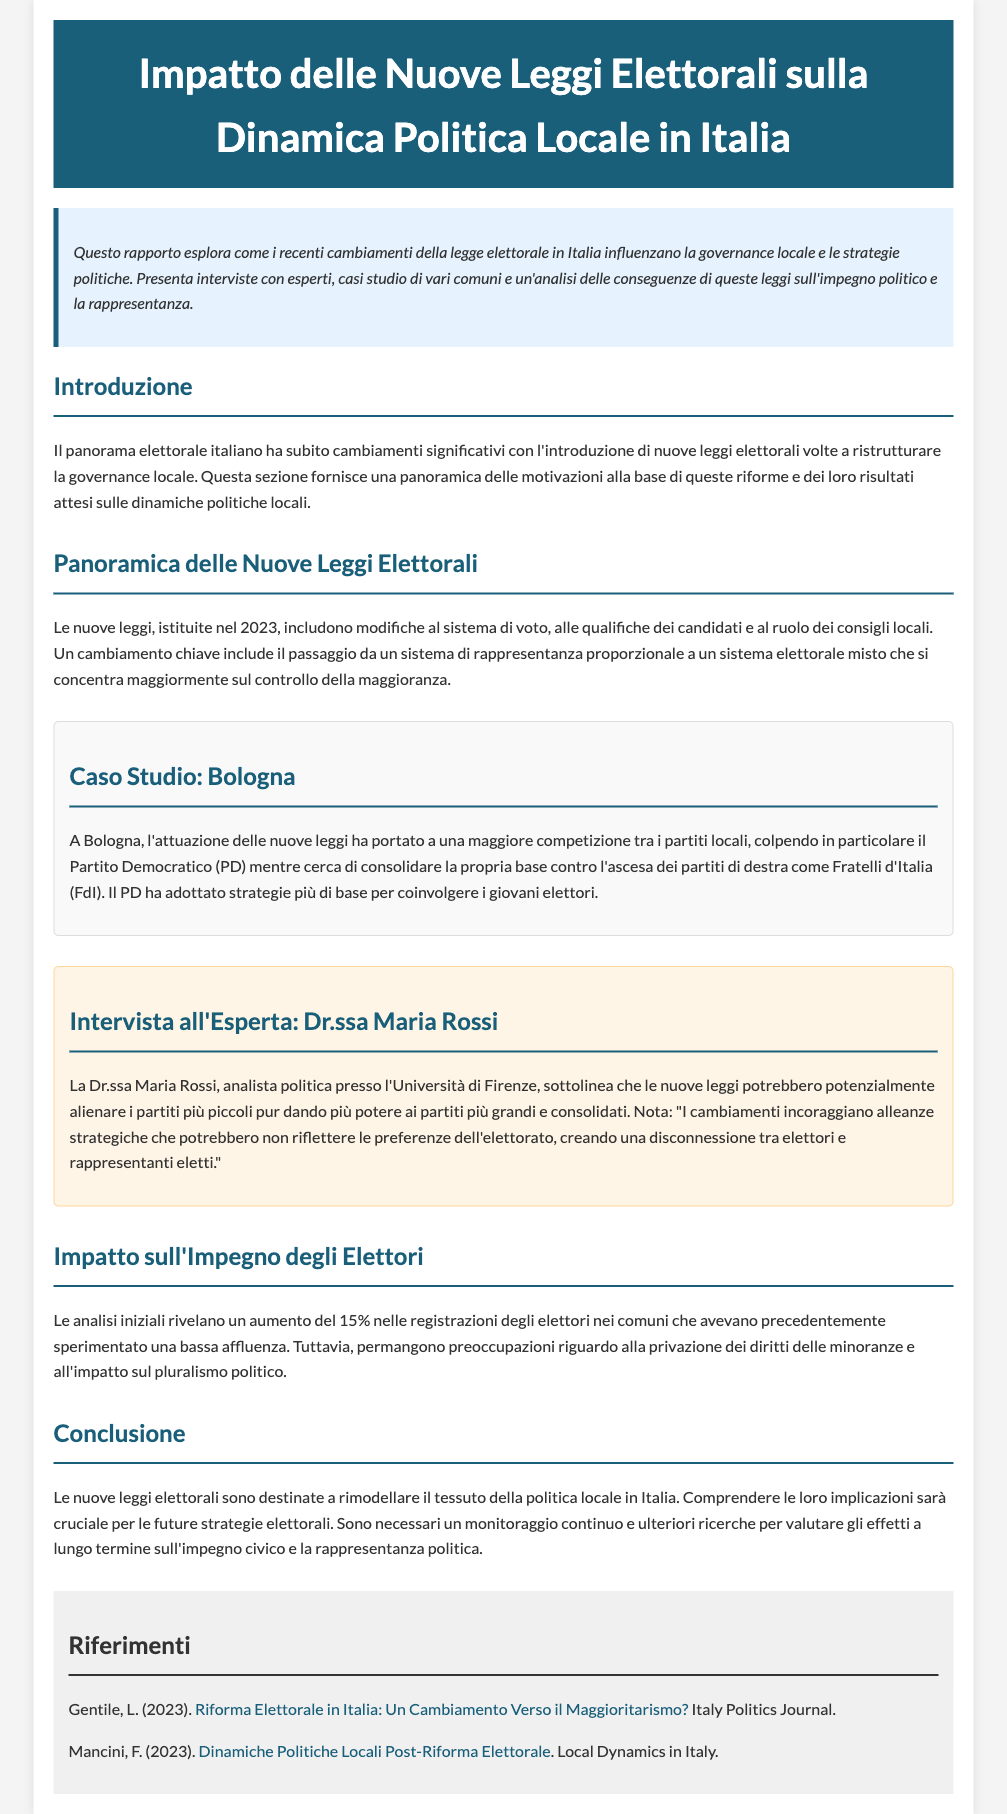what is the title of the document? The title is specified in the header section of the document.
Answer: Impatto delle Nuove Leggi Elettorali sulla Dinamica Politica Locale in Italia what year were the new electoral laws established? The document states that the new laws were instituted in a specific year.
Answer: 2023 who is the expert interviewed in the document? The expert's name is included in the interview section.
Answer: Dr.ssa Maria Rossi what political party is particularly affected in Bologna according to the case study? The document highlights the impact on a specific political party in Bologna.
Answer: Partito Democratico (PD) what percentage increase in voter registrations is mentioned? The document provides a specific figure related to voter registrations.
Answer: 15% what is the color of the headings used in the document? The document describes the style of the headings in the sections.
Answer: #1a5f7a what is a concern mentioned regarding the new electoral laws? The document lists concerns regarding the impact of the new laws.
Answer: privazione dei diritti delle minoranze what is the main focus of the new electoral law changes? The document defines the main focus of the new laws in relation to political representation.
Answer: controllo della maggioranza 